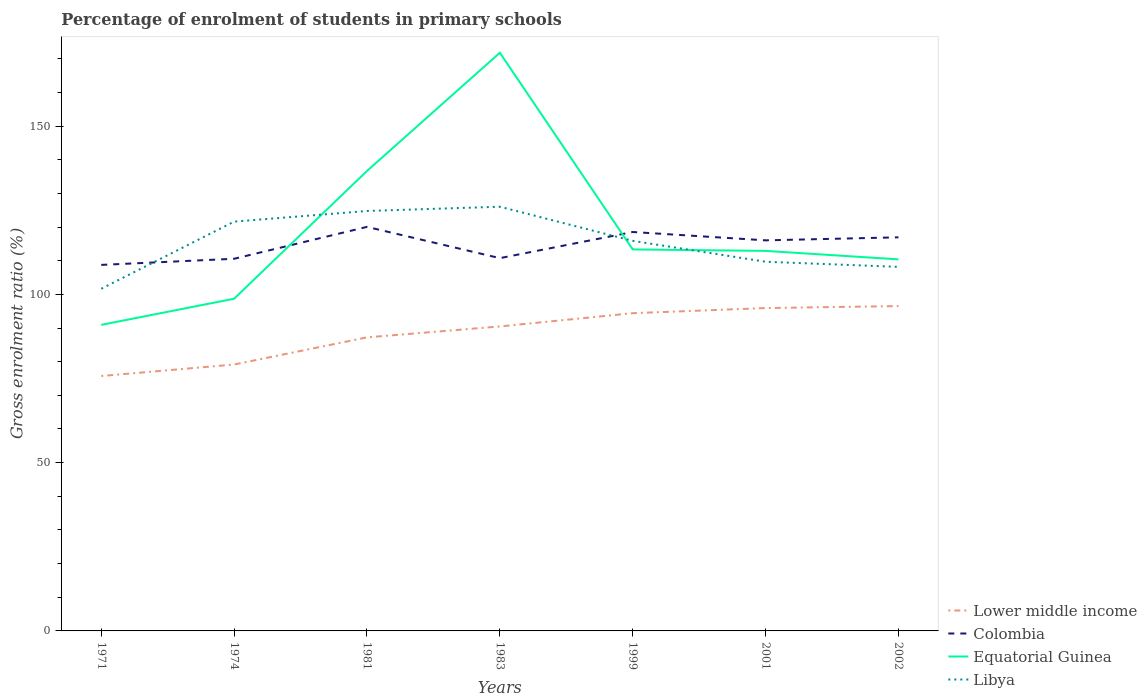How many different coloured lines are there?
Make the answer very short. 4. Is the number of lines equal to the number of legend labels?
Offer a very short reply. Yes. Across all years, what is the maximum percentage of students enrolled in primary schools in Colombia?
Offer a very short reply. 108.75. In which year was the percentage of students enrolled in primary schools in Equatorial Guinea maximum?
Ensure brevity in your answer.  1971. What is the total percentage of students enrolled in primary schools in Equatorial Guinea in the graph?
Ensure brevity in your answer.  -73.08. What is the difference between the highest and the second highest percentage of students enrolled in primary schools in Colombia?
Provide a succinct answer. 11.29. Is the percentage of students enrolled in primary schools in Libya strictly greater than the percentage of students enrolled in primary schools in Lower middle income over the years?
Make the answer very short. No. How many lines are there?
Offer a terse response. 4. What is the difference between two consecutive major ticks on the Y-axis?
Provide a short and direct response. 50. Are the values on the major ticks of Y-axis written in scientific E-notation?
Make the answer very short. No. How many legend labels are there?
Make the answer very short. 4. What is the title of the graph?
Your response must be concise. Percentage of enrolment of students in primary schools. Does "Belarus" appear as one of the legend labels in the graph?
Your answer should be very brief. No. What is the label or title of the Y-axis?
Make the answer very short. Gross enrolment ratio (%). What is the Gross enrolment ratio (%) of Lower middle income in 1971?
Your answer should be compact. 75.73. What is the Gross enrolment ratio (%) in Colombia in 1971?
Provide a short and direct response. 108.75. What is the Gross enrolment ratio (%) in Equatorial Guinea in 1971?
Ensure brevity in your answer.  90.93. What is the Gross enrolment ratio (%) of Libya in 1971?
Your answer should be compact. 101.67. What is the Gross enrolment ratio (%) of Lower middle income in 1974?
Keep it short and to the point. 79.15. What is the Gross enrolment ratio (%) of Colombia in 1974?
Provide a succinct answer. 110.57. What is the Gross enrolment ratio (%) of Equatorial Guinea in 1974?
Offer a terse response. 98.7. What is the Gross enrolment ratio (%) in Libya in 1974?
Ensure brevity in your answer.  121.61. What is the Gross enrolment ratio (%) in Lower middle income in 1981?
Offer a very short reply. 87.22. What is the Gross enrolment ratio (%) in Colombia in 1981?
Offer a terse response. 120.04. What is the Gross enrolment ratio (%) of Equatorial Guinea in 1981?
Provide a succinct answer. 136.66. What is the Gross enrolment ratio (%) of Libya in 1981?
Your answer should be very brief. 124.77. What is the Gross enrolment ratio (%) of Lower middle income in 1983?
Ensure brevity in your answer.  90.46. What is the Gross enrolment ratio (%) of Colombia in 1983?
Offer a very short reply. 110.76. What is the Gross enrolment ratio (%) of Equatorial Guinea in 1983?
Provide a short and direct response. 171.78. What is the Gross enrolment ratio (%) of Libya in 1983?
Make the answer very short. 126.03. What is the Gross enrolment ratio (%) in Lower middle income in 1999?
Offer a terse response. 94.4. What is the Gross enrolment ratio (%) of Colombia in 1999?
Your response must be concise. 118.52. What is the Gross enrolment ratio (%) of Equatorial Guinea in 1999?
Your response must be concise. 113.34. What is the Gross enrolment ratio (%) of Libya in 1999?
Give a very brief answer. 115.89. What is the Gross enrolment ratio (%) of Lower middle income in 2001?
Make the answer very short. 95.93. What is the Gross enrolment ratio (%) of Colombia in 2001?
Provide a succinct answer. 116.04. What is the Gross enrolment ratio (%) in Equatorial Guinea in 2001?
Offer a terse response. 112.91. What is the Gross enrolment ratio (%) in Libya in 2001?
Make the answer very short. 109.68. What is the Gross enrolment ratio (%) in Lower middle income in 2002?
Your answer should be very brief. 96.52. What is the Gross enrolment ratio (%) of Colombia in 2002?
Offer a terse response. 116.94. What is the Gross enrolment ratio (%) of Equatorial Guinea in 2002?
Make the answer very short. 110.39. What is the Gross enrolment ratio (%) of Libya in 2002?
Ensure brevity in your answer.  108.17. Across all years, what is the maximum Gross enrolment ratio (%) of Lower middle income?
Give a very brief answer. 96.52. Across all years, what is the maximum Gross enrolment ratio (%) in Colombia?
Your response must be concise. 120.04. Across all years, what is the maximum Gross enrolment ratio (%) in Equatorial Guinea?
Your answer should be very brief. 171.78. Across all years, what is the maximum Gross enrolment ratio (%) in Libya?
Your answer should be compact. 126.03. Across all years, what is the minimum Gross enrolment ratio (%) in Lower middle income?
Provide a succinct answer. 75.73. Across all years, what is the minimum Gross enrolment ratio (%) of Colombia?
Make the answer very short. 108.75. Across all years, what is the minimum Gross enrolment ratio (%) of Equatorial Guinea?
Your answer should be compact. 90.93. Across all years, what is the minimum Gross enrolment ratio (%) of Libya?
Keep it short and to the point. 101.67. What is the total Gross enrolment ratio (%) in Lower middle income in the graph?
Offer a terse response. 619.41. What is the total Gross enrolment ratio (%) of Colombia in the graph?
Provide a succinct answer. 801.63. What is the total Gross enrolment ratio (%) in Equatorial Guinea in the graph?
Offer a very short reply. 834.72. What is the total Gross enrolment ratio (%) of Libya in the graph?
Ensure brevity in your answer.  807.82. What is the difference between the Gross enrolment ratio (%) in Lower middle income in 1971 and that in 1974?
Offer a terse response. -3.42. What is the difference between the Gross enrolment ratio (%) of Colombia in 1971 and that in 1974?
Your answer should be compact. -1.82. What is the difference between the Gross enrolment ratio (%) in Equatorial Guinea in 1971 and that in 1974?
Offer a terse response. -7.77. What is the difference between the Gross enrolment ratio (%) of Libya in 1971 and that in 1974?
Your answer should be very brief. -19.94. What is the difference between the Gross enrolment ratio (%) of Lower middle income in 1971 and that in 1981?
Provide a short and direct response. -11.48. What is the difference between the Gross enrolment ratio (%) of Colombia in 1971 and that in 1981?
Provide a succinct answer. -11.29. What is the difference between the Gross enrolment ratio (%) of Equatorial Guinea in 1971 and that in 1981?
Provide a short and direct response. -45.73. What is the difference between the Gross enrolment ratio (%) in Libya in 1971 and that in 1981?
Provide a short and direct response. -23.11. What is the difference between the Gross enrolment ratio (%) of Lower middle income in 1971 and that in 1983?
Give a very brief answer. -14.73. What is the difference between the Gross enrolment ratio (%) in Colombia in 1971 and that in 1983?
Ensure brevity in your answer.  -2.01. What is the difference between the Gross enrolment ratio (%) in Equatorial Guinea in 1971 and that in 1983?
Make the answer very short. -80.85. What is the difference between the Gross enrolment ratio (%) of Libya in 1971 and that in 1983?
Ensure brevity in your answer.  -24.37. What is the difference between the Gross enrolment ratio (%) in Lower middle income in 1971 and that in 1999?
Your response must be concise. -18.67. What is the difference between the Gross enrolment ratio (%) of Colombia in 1971 and that in 1999?
Give a very brief answer. -9.77. What is the difference between the Gross enrolment ratio (%) of Equatorial Guinea in 1971 and that in 1999?
Keep it short and to the point. -22.41. What is the difference between the Gross enrolment ratio (%) of Libya in 1971 and that in 1999?
Give a very brief answer. -14.22. What is the difference between the Gross enrolment ratio (%) of Lower middle income in 1971 and that in 2001?
Your answer should be compact. -20.19. What is the difference between the Gross enrolment ratio (%) in Colombia in 1971 and that in 2001?
Your answer should be compact. -7.29. What is the difference between the Gross enrolment ratio (%) of Equatorial Guinea in 1971 and that in 2001?
Your response must be concise. -21.97. What is the difference between the Gross enrolment ratio (%) of Libya in 1971 and that in 2001?
Offer a very short reply. -8.02. What is the difference between the Gross enrolment ratio (%) of Lower middle income in 1971 and that in 2002?
Your answer should be very brief. -20.78. What is the difference between the Gross enrolment ratio (%) of Colombia in 1971 and that in 2002?
Keep it short and to the point. -8.19. What is the difference between the Gross enrolment ratio (%) in Equatorial Guinea in 1971 and that in 2002?
Offer a very short reply. -19.46. What is the difference between the Gross enrolment ratio (%) in Libya in 1971 and that in 2002?
Keep it short and to the point. -6.5. What is the difference between the Gross enrolment ratio (%) of Lower middle income in 1974 and that in 1981?
Provide a short and direct response. -8.06. What is the difference between the Gross enrolment ratio (%) of Colombia in 1974 and that in 1981?
Your answer should be compact. -9.47. What is the difference between the Gross enrolment ratio (%) of Equatorial Guinea in 1974 and that in 1981?
Give a very brief answer. -37.96. What is the difference between the Gross enrolment ratio (%) of Libya in 1974 and that in 1981?
Your response must be concise. -3.16. What is the difference between the Gross enrolment ratio (%) of Lower middle income in 1974 and that in 1983?
Your response must be concise. -11.31. What is the difference between the Gross enrolment ratio (%) in Colombia in 1974 and that in 1983?
Your response must be concise. -0.19. What is the difference between the Gross enrolment ratio (%) of Equatorial Guinea in 1974 and that in 1983?
Provide a succinct answer. -73.08. What is the difference between the Gross enrolment ratio (%) in Libya in 1974 and that in 1983?
Your answer should be compact. -4.43. What is the difference between the Gross enrolment ratio (%) in Lower middle income in 1974 and that in 1999?
Ensure brevity in your answer.  -15.25. What is the difference between the Gross enrolment ratio (%) in Colombia in 1974 and that in 1999?
Your answer should be very brief. -7.95. What is the difference between the Gross enrolment ratio (%) of Equatorial Guinea in 1974 and that in 1999?
Your response must be concise. -14.64. What is the difference between the Gross enrolment ratio (%) in Libya in 1974 and that in 1999?
Your response must be concise. 5.72. What is the difference between the Gross enrolment ratio (%) of Lower middle income in 1974 and that in 2001?
Ensure brevity in your answer.  -16.77. What is the difference between the Gross enrolment ratio (%) in Colombia in 1974 and that in 2001?
Make the answer very short. -5.47. What is the difference between the Gross enrolment ratio (%) of Equatorial Guinea in 1974 and that in 2001?
Keep it short and to the point. -14.21. What is the difference between the Gross enrolment ratio (%) of Libya in 1974 and that in 2001?
Offer a terse response. 11.92. What is the difference between the Gross enrolment ratio (%) in Lower middle income in 1974 and that in 2002?
Your answer should be compact. -17.37. What is the difference between the Gross enrolment ratio (%) in Colombia in 1974 and that in 2002?
Offer a terse response. -6.37. What is the difference between the Gross enrolment ratio (%) of Equatorial Guinea in 1974 and that in 2002?
Ensure brevity in your answer.  -11.69. What is the difference between the Gross enrolment ratio (%) of Libya in 1974 and that in 2002?
Give a very brief answer. 13.44. What is the difference between the Gross enrolment ratio (%) of Lower middle income in 1981 and that in 1983?
Keep it short and to the point. -3.25. What is the difference between the Gross enrolment ratio (%) in Colombia in 1981 and that in 1983?
Keep it short and to the point. 9.28. What is the difference between the Gross enrolment ratio (%) in Equatorial Guinea in 1981 and that in 1983?
Make the answer very short. -35.12. What is the difference between the Gross enrolment ratio (%) in Libya in 1981 and that in 1983?
Your answer should be very brief. -1.26. What is the difference between the Gross enrolment ratio (%) in Lower middle income in 1981 and that in 1999?
Give a very brief answer. -7.18. What is the difference between the Gross enrolment ratio (%) of Colombia in 1981 and that in 1999?
Make the answer very short. 1.52. What is the difference between the Gross enrolment ratio (%) in Equatorial Guinea in 1981 and that in 1999?
Your answer should be very brief. 23.31. What is the difference between the Gross enrolment ratio (%) in Libya in 1981 and that in 1999?
Your answer should be compact. 8.88. What is the difference between the Gross enrolment ratio (%) in Lower middle income in 1981 and that in 2001?
Provide a short and direct response. -8.71. What is the difference between the Gross enrolment ratio (%) in Colombia in 1981 and that in 2001?
Your answer should be compact. 4. What is the difference between the Gross enrolment ratio (%) of Equatorial Guinea in 1981 and that in 2001?
Make the answer very short. 23.75. What is the difference between the Gross enrolment ratio (%) of Libya in 1981 and that in 2001?
Offer a terse response. 15.09. What is the difference between the Gross enrolment ratio (%) of Lower middle income in 1981 and that in 2002?
Your answer should be very brief. -9.3. What is the difference between the Gross enrolment ratio (%) of Colombia in 1981 and that in 2002?
Your answer should be compact. 3.1. What is the difference between the Gross enrolment ratio (%) in Equatorial Guinea in 1981 and that in 2002?
Offer a very short reply. 26.27. What is the difference between the Gross enrolment ratio (%) of Libya in 1981 and that in 2002?
Provide a succinct answer. 16.6. What is the difference between the Gross enrolment ratio (%) in Lower middle income in 1983 and that in 1999?
Offer a very short reply. -3.94. What is the difference between the Gross enrolment ratio (%) in Colombia in 1983 and that in 1999?
Your answer should be compact. -7.76. What is the difference between the Gross enrolment ratio (%) in Equatorial Guinea in 1983 and that in 1999?
Give a very brief answer. 58.44. What is the difference between the Gross enrolment ratio (%) in Libya in 1983 and that in 1999?
Your response must be concise. 10.14. What is the difference between the Gross enrolment ratio (%) of Lower middle income in 1983 and that in 2001?
Make the answer very short. -5.46. What is the difference between the Gross enrolment ratio (%) in Colombia in 1983 and that in 2001?
Ensure brevity in your answer.  -5.29. What is the difference between the Gross enrolment ratio (%) of Equatorial Guinea in 1983 and that in 2001?
Ensure brevity in your answer.  58.88. What is the difference between the Gross enrolment ratio (%) in Libya in 1983 and that in 2001?
Provide a succinct answer. 16.35. What is the difference between the Gross enrolment ratio (%) in Lower middle income in 1983 and that in 2002?
Offer a terse response. -6.05. What is the difference between the Gross enrolment ratio (%) of Colombia in 1983 and that in 2002?
Provide a succinct answer. -6.18. What is the difference between the Gross enrolment ratio (%) in Equatorial Guinea in 1983 and that in 2002?
Provide a succinct answer. 61.39. What is the difference between the Gross enrolment ratio (%) of Libya in 1983 and that in 2002?
Your answer should be compact. 17.87. What is the difference between the Gross enrolment ratio (%) in Lower middle income in 1999 and that in 2001?
Offer a terse response. -1.53. What is the difference between the Gross enrolment ratio (%) of Colombia in 1999 and that in 2001?
Give a very brief answer. 2.48. What is the difference between the Gross enrolment ratio (%) of Equatorial Guinea in 1999 and that in 2001?
Offer a very short reply. 0.44. What is the difference between the Gross enrolment ratio (%) in Libya in 1999 and that in 2001?
Provide a succinct answer. 6.21. What is the difference between the Gross enrolment ratio (%) of Lower middle income in 1999 and that in 2002?
Give a very brief answer. -2.12. What is the difference between the Gross enrolment ratio (%) in Colombia in 1999 and that in 2002?
Offer a very short reply. 1.58. What is the difference between the Gross enrolment ratio (%) of Equatorial Guinea in 1999 and that in 2002?
Your answer should be very brief. 2.95. What is the difference between the Gross enrolment ratio (%) in Libya in 1999 and that in 2002?
Your answer should be very brief. 7.72. What is the difference between the Gross enrolment ratio (%) in Lower middle income in 2001 and that in 2002?
Make the answer very short. -0.59. What is the difference between the Gross enrolment ratio (%) of Colombia in 2001 and that in 2002?
Give a very brief answer. -0.9. What is the difference between the Gross enrolment ratio (%) of Equatorial Guinea in 2001 and that in 2002?
Keep it short and to the point. 2.51. What is the difference between the Gross enrolment ratio (%) in Libya in 2001 and that in 2002?
Make the answer very short. 1.52. What is the difference between the Gross enrolment ratio (%) of Lower middle income in 1971 and the Gross enrolment ratio (%) of Colombia in 1974?
Your answer should be very brief. -34.84. What is the difference between the Gross enrolment ratio (%) of Lower middle income in 1971 and the Gross enrolment ratio (%) of Equatorial Guinea in 1974?
Provide a succinct answer. -22.97. What is the difference between the Gross enrolment ratio (%) in Lower middle income in 1971 and the Gross enrolment ratio (%) in Libya in 1974?
Ensure brevity in your answer.  -45.87. What is the difference between the Gross enrolment ratio (%) in Colombia in 1971 and the Gross enrolment ratio (%) in Equatorial Guinea in 1974?
Your answer should be compact. 10.05. What is the difference between the Gross enrolment ratio (%) of Colombia in 1971 and the Gross enrolment ratio (%) of Libya in 1974?
Ensure brevity in your answer.  -12.86. What is the difference between the Gross enrolment ratio (%) of Equatorial Guinea in 1971 and the Gross enrolment ratio (%) of Libya in 1974?
Ensure brevity in your answer.  -30.67. What is the difference between the Gross enrolment ratio (%) of Lower middle income in 1971 and the Gross enrolment ratio (%) of Colombia in 1981?
Provide a succinct answer. -44.31. What is the difference between the Gross enrolment ratio (%) in Lower middle income in 1971 and the Gross enrolment ratio (%) in Equatorial Guinea in 1981?
Offer a very short reply. -60.92. What is the difference between the Gross enrolment ratio (%) of Lower middle income in 1971 and the Gross enrolment ratio (%) of Libya in 1981?
Ensure brevity in your answer.  -49.04. What is the difference between the Gross enrolment ratio (%) of Colombia in 1971 and the Gross enrolment ratio (%) of Equatorial Guinea in 1981?
Ensure brevity in your answer.  -27.91. What is the difference between the Gross enrolment ratio (%) of Colombia in 1971 and the Gross enrolment ratio (%) of Libya in 1981?
Keep it short and to the point. -16.02. What is the difference between the Gross enrolment ratio (%) in Equatorial Guinea in 1971 and the Gross enrolment ratio (%) in Libya in 1981?
Your answer should be compact. -33.84. What is the difference between the Gross enrolment ratio (%) in Lower middle income in 1971 and the Gross enrolment ratio (%) in Colombia in 1983?
Ensure brevity in your answer.  -35.02. What is the difference between the Gross enrolment ratio (%) in Lower middle income in 1971 and the Gross enrolment ratio (%) in Equatorial Guinea in 1983?
Provide a short and direct response. -96.05. What is the difference between the Gross enrolment ratio (%) of Lower middle income in 1971 and the Gross enrolment ratio (%) of Libya in 1983?
Ensure brevity in your answer.  -50.3. What is the difference between the Gross enrolment ratio (%) of Colombia in 1971 and the Gross enrolment ratio (%) of Equatorial Guinea in 1983?
Your answer should be compact. -63.03. What is the difference between the Gross enrolment ratio (%) of Colombia in 1971 and the Gross enrolment ratio (%) of Libya in 1983?
Offer a very short reply. -17.28. What is the difference between the Gross enrolment ratio (%) of Equatorial Guinea in 1971 and the Gross enrolment ratio (%) of Libya in 1983?
Offer a terse response. -35.1. What is the difference between the Gross enrolment ratio (%) in Lower middle income in 1971 and the Gross enrolment ratio (%) in Colombia in 1999?
Your response must be concise. -42.79. What is the difference between the Gross enrolment ratio (%) in Lower middle income in 1971 and the Gross enrolment ratio (%) in Equatorial Guinea in 1999?
Offer a terse response. -37.61. What is the difference between the Gross enrolment ratio (%) of Lower middle income in 1971 and the Gross enrolment ratio (%) of Libya in 1999?
Your answer should be compact. -40.16. What is the difference between the Gross enrolment ratio (%) of Colombia in 1971 and the Gross enrolment ratio (%) of Equatorial Guinea in 1999?
Your answer should be compact. -4.59. What is the difference between the Gross enrolment ratio (%) of Colombia in 1971 and the Gross enrolment ratio (%) of Libya in 1999?
Your answer should be very brief. -7.14. What is the difference between the Gross enrolment ratio (%) in Equatorial Guinea in 1971 and the Gross enrolment ratio (%) in Libya in 1999?
Make the answer very short. -24.96. What is the difference between the Gross enrolment ratio (%) in Lower middle income in 1971 and the Gross enrolment ratio (%) in Colombia in 2001?
Make the answer very short. -40.31. What is the difference between the Gross enrolment ratio (%) of Lower middle income in 1971 and the Gross enrolment ratio (%) of Equatorial Guinea in 2001?
Ensure brevity in your answer.  -37.17. What is the difference between the Gross enrolment ratio (%) in Lower middle income in 1971 and the Gross enrolment ratio (%) in Libya in 2001?
Give a very brief answer. -33.95. What is the difference between the Gross enrolment ratio (%) of Colombia in 1971 and the Gross enrolment ratio (%) of Equatorial Guinea in 2001?
Offer a terse response. -4.15. What is the difference between the Gross enrolment ratio (%) of Colombia in 1971 and the Gross enrolment ratio (%) of Libya in 2001?
Give a very brief answer. -0.93. What is the difference between the Gross enrolment ratio (%) in Equatorial Guinea in 1971 and the Gross enrolment ratio (%) in Libya in 2001?
Your response must be concise. -18.75. What is the difference between the Gross enrolment ratio (%) of Lower middle income in 1971 and the Gross enrolment ratio (%) of Colombia in 2002?
Ensure brevity in your answer.  -41.21. What is the difference between the Gross enrolment ratio (%) of Lower middle income in 1971 and the Gross enrolment ratio (%) of Equatorial Guinea in 2002?
Keep it short and to the point. -34.66. What is the difference between the Gross enrolment ratio (%) in Lower middle income in 1971 and the Gross enrolment ratio (%) in Libya in 2002?
Your response must be concise. -32.43. What is the difference between the Gross enrolment ratio (%) of Colombia in 1971 and the Gross enrolment ratio (%) of Equatorial Guinea in 2002?
Offer a terse response. -1.64. What is the difference between the Gross enrolment ratio (%) in Colombia in 1971 and the Gross enrolment ratio (%) in Libya in 2002?
Offer a terse response. 0.58. What is the difference between the Gross enrolment ratio (%) of Equatorial Guinea in 1971 and the Gross enrolment ratio (%) of Libya in 2002?
Provide a succinct answer. -17.23. What is the difference between the Gross enrolment ratio (%) in Lower middle income in 1974 and the Gross enrolment ratio (%) in Colombia in 1981?
Keep it short and to the point. -40.89. What is the difference between the Gross enrolment ratio (%) in Lower middle income in 1974 and the Gross enrolment ratio (%) in Equatorial Guinea in 1981?
Provide a succinct answer. -57.51. What is the difference between the Gross enrolment ratio (%) of Lower middle income in 1974 and the Gross enrolment ratio (%) of Libya in 1981?
Offer a terse response. -45.62. What is the difference between the Gross enrolment ratio (%) of Colombia in 1974 and the Gross enrolment ratio (%) of Equatorial Guinea in 1981?
Your answer should be compact. -26.09. What is the difference between the Gross enrolment ratio (%) in Colombia in 1974 and the Gross enrolment ratio (%) in Libya in 1981?
Give a very brief answer. -14.2. What is the difference between the Gross enrolment ratio (%) in Equatorial Guinea in 1974 and the Gross enrolment ratio (%) in Libya in 1981?
Offer a terse response. -26.07. What is the difference between the Gross enrolment ratio (%) in Lower middle income in 1974 and the Gross enrolment ratio (%) in Colombia in 1983?
Ensure brevity in your answer.  -31.61. What is the difference between the Gross enrolment ratio (%) in Lower middle income in 1974 and the Gross enrolment ratio (%) in Equatorial Guinea in 1983?
Give a very brief answer. -92.63. What is the difference between the Gross enrolment ratio (%) in Lower middle income in 1974 and the Gross enrolment ratio (%) in Libya in 1983?
Provide a short and direct response. -46.88. What is the difference between the Gross enrolment ratio (%) of Colombia in 1974 and the Gross enrolment ratio (%) of Equatorial Guinea in 1983?
Provide a short and direct response. -61.21. What is the difference between the Gross enrolment ratio (%) of Colombia in 1974 and the Gross enrolment ratio (%) of Libya in 1983?
Keep it short and to the point. -15.46. What is the difference between the Gross enrolment ratio (%) in Equatorial Guinea in 1974 and the Gross enrolment ratio (%) in Libya in 1983?
Ensure brevity in your answer.  -27.33. What is the difference between the Gross enrolment ratio (%) in Lower middle income in 1974 and the Gross enrolment ratio (%) in Colombia in 1999?
Offer a very short reply. -39.37. What is the difference between the Gross enrolment ratio (%) in Lower middle income in 1974 and the Gross enrolment ratio (%) in Equatorial Guinea in 1999?
Ensure brevity in your answer.  -34.19. What is the difference between the Gross enrolment ratio (%) in Lower middle income in 1974 and the Gross enrolment ratio (%) in Libya in 1999?
Keep it short and to the point. -36.74. What is the difference between the Gross enrolment ratio (%) in Colombia in 1974 and the Gross enrolment ratio (%) in Equatorial Guinea in 1999?
Give a very brief answer. -2.77. What is the difference between the Gross enrolment ratio (%) of Colombia in 1974 and the Gross enrolment ratio (%) of Libya in 1999?
Offer a very short reply. -5.32. What is the difference between the Gross enrolment ratio (%) in Equatorial Guinea in 1974 and the Gross enrolment ratio (%) in Libya in 1999?
Provide a short and direct response. -17.19. What is the difference between the Gross enrolment ratio (%) in Lower middle income in 1974 and the Gross enrolment ratio (%) in Colombia in 2001?
Your answer should be compact. -36.89. What is the difference between the Gross enrolment ratio (%) in Lower middle income in 1974 and the Gross enrolment ratio (%) in Equatorial Guinea in 2001?
Make the answer very short. -33.75. What is the difference between the Gross enrolment ratio (%) in Lower middle income in 1974 and the Gross enrolment ratio (%) in Libya in 2001?
Provide a succinct answer. -30.53. What is the difference between the Gross enrolment ratio (%) in Colombia in 1974 and the Gross enrolment ratio (%) in Equatorial Guinea in 2001?
Keep it short and to the point. -2.33. What is the difference between the Gross enrolment ratio (%) in Colombia in 1974 and the Gross enrolment ratio (%) in Libya in 2001?
Provide a short and direct response. 0.89. What is the difference between the Gross enrolment ratio (%) in Equatorial Guinea in 1974 and the Gross enrolment ratio (%) in Libya in 2001?
Your response must be concise. -10.98. What is the difference between the Gross enrolment ratio (%) in Lower middle income in 1974 and the Gross enrolment ratio (%) in Colombia in 2002?
Your answer should be compact. -37.79. What is the difference between the Gross enrolment ratio (%) in Lower middle income in 1974 and the Gross enrolment ratio (%) in Equatorial Guinea in 2002?
Make the answer very short. -31.24. What is the difference between the Gross enrolment ratio (%) of Lower middle income in 1974 and the Gross enrolment ratio (%) of Libya in 2002?
Give a very brief answer. -29.01. What is the difference between the Gross enrolment ratio (%) of Colombia in 1974 and the Gross enrolment ratio (%) of Equatorial Guinea in 2002?
Your answer should be compact. 0.18. What is the difference between the Gross enrolment ratio (%) in Colombia in 1974 and the Gross enrolment ratio (%) in Libya in 2002?
Your answer should be compact. 2.4. What is the difference between the Gross enrolment ratio (%) in Equatorial Guinea in 1974 and the Gross enrolment ratio (%) in Libya in 2002?
Give a very brief answer. -9.47. What is the difference between the Gross enrolment ratio (%) of Lower middle income in 1981 and the Gross enrolment ratio (%) of Colombia in 1983?
Keep it short and to the point. -23.54. What is the difference between the Gross enrolment ratio (%) in Lower middle income in 1981 and the Gross enrolment ratio (%) in Equatorial Guinea in 1983?
Provide a short and direct response. -84.57. What is the difference between the Gross enrolment ratio (%) in Lower middle income in 1981 and the Gross enrolment ratio (%) in Libya in 1983?
Your answer should be very brief. -38.82. What is the difference between the Gross enrolment ratio (%) in Colombia in 1981 and the Gross enrolment ratio (%) in Equatorial Guinea in 1983?
Your answer should be very brief. -51.74. What is the difference between the Gross enrolment ratio (%) in Colombia in 1981 and the Gross enrolment ratio (%) in Libya in 1983?
Offer a very short reply. -5.99. What is the difference between the Gross enrolment ratio (%) in Equatorial Guinea in 1981 and the Gross enrolment ratio (%) in Libya in 1983?
Ensure brevity in your answer.  10.63. What is the difference between the Gross enrolment ratio (%) in Lower middle income in 1981 and the Gross enrolment ratio (%) in Colombia in 1999?
Your response must be concise. -31.31. What is the difference between the Gross enrolment ratio (%) of Lower middle income in 1981 and the Gross enrolment ratio (%) of Equatorial Guinea in 1999?
Your response must be concise. -26.13. What is the difference between the Gross enrolment ratio (%) of Lower middle income in 1981 and the Gross enrolment ratio (%) of Libya in 1999?
Provide a succinct answer. -28.67. What is the difference between the Gross enrolment ratio (%) in Colombia in 1981 and the Gross enrolment ratio (%) in Equatorial Guinea in 1999?
Offer a very short reply. 6.7. What is the difference between the Gross enrolment ratio (%) in Colombia in 1981 and the Gross enrolment ratio (%) in Libya in 1999?
Your answer should be very brief. 4.15. What is the difference between the Gross enrolment ratio (%) in Equatorial Guinea in 1981 and the Gross enrolment ratio (%) in Libya in 1999?
Keep it short and to the point. 20.77. What is the difference between the Gross enrolment ratio (%) in Lower middle income in 1981 and the Gross enrolment ratio (%) in Colombia in 2001?
Ensure brevity in your answer.  -28.83. What is the difference between the Gross enrolment ratio (%) in Lower middle income in 1981 and the Gross enrolment ratio (%) in Equatorial Guinea in 2001?
Keep it short and to the point. -25.69. What is the difference between the Gross enrolment ratio (%) in Lower middle income in 1981 and the Gross enrolment ratio (%) in Libya in 2001?
Offer a very short reply. -22.47. What is the difference between the Gross enrolment ratio (%) of Colombia in 1981 and the Gross enrolment ratio (%) of Equatorial Guinea in 2001?
Ensure brevity in your answer.  7.14. What is the difference between the Gross enrolment ratio (%) of Colombia in 1981 and the Gross enrolment ratio (%) of Libya in 2001?
Ensure brevity in your answer.  10.36. What is the difference between the Gross enrolment ratio (%) of Equatorial Guinea in 1981 and the Gross enrolment ratio (%) of Libya in 2001?
Your answer should be compact. 26.98. What is the difference between the Gross enrolment ratio (%) of Lower middle income in 1981 and the Gross enrolment ratio (%) of Colombia in 2002?
Give a very brief answer. -29.73. What is the difference between the Gross enrolment ratio (%) in Lower middle income in 1981 and the Gross enrolment ratio (%) in Equatorial Guinea in 2002?
Ensure brevity in your answer.  -23.18. What is the difference between the Gross enrolment ratio (%) of Lower middle income in 1981 and the Gross enrolment ratio (%) of Libya in 2002?
Offer a very short reply. -20.95. What is the difference between the Gross enrolment ratio (%) of Colombia in 1981 and the Gross enrolment ratio (%) of Equatorial Guinea in 2002?
Provide a short and direct response. 9.65. What is the difference between the Gross enrolment ratio (%) of Colombia in 1981 and the Gross enrolment ratio (%) of Libya in 2002?
Your answer should be very brief. 11.87. What is the difference between the Gross enrolment ratio (%) in Equatorial Guinea in 1981 and the Gross enrolment ratio (%) in Libya in 2002?
Your answer should be compact. 28.49. What is the difference between the Gross enrolment ratio (%) in Lower middle income in 1983 and the Gross enrolment ratio (%) in Colombia in 1999?
Offer a very short reply. -28.06. What is the difference between the Gross enrolment ratio (%) in Lower middle income in 1983 and the Gross enrolment ratio (%) in Equatorial Guinea in 1999?
Your response must be concise. -22.88. What is the difference between the Gross enrolment ratio (%) of Lower middle income in 1983 and the Gross enrolment ratio (%) of Libya in 1999?
Provide a short and direct response. -25.43. What is the difference between the Gross enrolment ratio (%) of Colombia in 1983 and the Gross enrolment ratio (%) of Equatorial Guinea in 1999?
Your answer should be very brief. -2.59. What is the difference between the Gross enrolment ratio (%) of Colombia in 1983 and the Gross enrolment ratio (%) of Libya in 1999?
Offer a very short reply. -5.13. What is the difference between the Gross enrolment ratio (%) of Equatorial Guinea in 1983 and the Gross enrolment ratio (%) of Libya in 1999?
Provide a short and direct response. 55.89. What is the difference between the Gross enrolment ratio (%) in Lower middle income in 1983 and the Gross enrolment ratio (%) in Colombia in 2001?
Your answer should be very brief. -25.58. What is the difference between the Gross enrolment ratio (%) in Lower middle income in 1983 and the Gross enrolment ratio (%) in Equatorial Guinea in 2001?
Your answer should be compact. -22.44. What is the difference between the Gross enrolment ratio (%) of Lower middle income in 1983 and the Gross enrolment ratio (%) of Libya in 2001?
Your response must be concise. -19.22. What is the difference between the Gross enrolment ratio (%) of Colombia in 1983 and the Gross enrolment ratio (%) of Equatorial Guinea in 2001?
Provide a short and direct response. -2.15. What is the difference between the Gross enrolment ratio (%) of Colombia in 1983 and the Gross enrolment ratio (%) of Libya in 2001?
Offer a very short reply. 1.07. What is the difference between the Gross enrolment ratio (%) in Equatorial Guinea in 1983 and the Gross enrolment ratio (%) in Libya in 2001?
Offer a very short reply. 62.1. What is the difference between the Gross enrolment ratio (%) in Lower middle income in 1983 and the Gross enrolment ratio (%) in Colombia in 2002?
Offer a very short reply. -26.48. What is the difference between the Gross enrolment ratio (%) of Lower middle income in 1983 and the Gross enrolment ratio (%) of Equatorial Guinea in 2002?
Provide a succinct answer. -19.93. What is the difference between the Gross enrolment ratio (%) in Lower middle income in 1983 and the Gross enrolment ratio (%) in Libya in 2002?
Your response must be concise. -17.7. What is the difference between the Gross enrolment ratio (%) of Colombia in 1983 and the Gross enrolment ratio (%) of Equatorial Guinea in 2002?
Your answer should be very brief. 0.36. What is the difference between the Gross enrolment ratio (%) in Colombia in 1983 and the Gross enrolment ratio (%) in Libya in 2002?
Make the answer very short. 2.59. What is the difference between the Gross enrolment ratio (%) of Equatorial Guinea in 1983 and the Gross enrolment ratio (%) of Libya in 2002?
Offer a terse response. 63.62. What is the difference between the Gross enrolment ratio (%) in Lower middle income in 1999 and the Gross enrolment ratio (%) in Colombia in 2001?
Offer a terse response. -21.64. What is the difference between the Gross enrolment ratio (%) in Lower middle income in 1999 and the Gross enrolment ratio (%) in Equatorial Guinea in 2001?
Keep it short and to the point. -18.5. What is the difference between the Gross enrolment ratio (%) in Lower middle income in 1999 and the Gross enrolment ratio (%) in Libya in 2001?
Your response must be concise. -15.28. What is the difference between the Gross enrolment ratio (%) in Colombia in 1999 and the Gross enrolment ratio (%) in Equatorial Guinea in 2001?
Offer a terse response. 5.62. What is the difference between the Gross enrolment ratio (%) in Colombia in 1999 and the Gross enrolment ratio (%) in Libya in 2001?
Give a very brief answer. 8.84. What is the difference between the Gross enrolment ratio (%) in Equatorial Guinea in 1999 and the Gross enrolment ratio (%) in Libya in 2001?
Provide a succinct answer. 3.66. What is the difference between the Gross enrolment ratio (%) of Lower middle income in 1999 and the Gross enrolment ratio (%) of Colombia in 2002?
Offer a very short reply. -22.54. What is the difference between the Gross enrolment ratio (%) in Lower middle income in 1999 and the Gross enrolment ratio (%) in Equatorial Guinea in 2002?
Provide a short and direct response. -15.99. What is the difference between the Gross enrolment ratio (%) of Lower middle income in 1999 and the Gross enrolment ratio (%) of Libya in 2002?
Ensure brevity in your answer.  -13.77. What is the difference between the Gross enrolment ratio (%) in Colombia in 1999 and the Gross enrolment ratio (%) in Equatorial Guinea in 2002?
Offer a very short reply. 8.13. What is the difference between the Gross enrolment ratio (%) of Colombia in 1999 and the Gross enrolment ratio (%) of Libya in 2002?
Your response must be concise. 10.36. What is the difference between the Gross enrolment ratio (%) of Equatorial Guinea in 1999 and the Gross enrolment ratio (%) of Libya in 2002?
Offer a very short reply. 5.18. What is the difference between the Gross enrolment ratio (%) in Lower middle income in 2001 and the Gross enrolment ratio (%) in Colombia in 2002?
Ensure brevity in your answer.  -21.01. What is the difference between the Gross enrolment ratio (%) in Lower middle income in 2001 and the Gross enrolment ratio (%) in Equatorial Guinea in 2002?
Provide a succinct answer. -14.47. What is the difference between the Gross enrolment ratio (%) of Lower middle income in 2001 and the Gross enrolment ratio (%) of Libya in 2002?
Your answer should be very brief. -12.24. What is the difference between the Gross enrolment ratio (%) of Colombia in 2001 and the Gross enrolment ratio (%) of Equatorial Guinea in 2002?
Your answer should be compact. 5.65. What is the difference between the Gross enrolment ratio (%) of Colombia in 2001 and the Gross enrolment ratio (%) of Libya in 2002?
Provide a short and direct response. 7.88. What is the difference between the Gross enrolment ratio (%) of Equatorial Guinea in 2001 and the Gross enrolment ratio (%) of Libya in 2002?
Ensure brevity in your answer.  4.74. What is the average Gross enrolment ratio (%) in Lower middle income per year?
Your answer should be very brief. 88.49. What is the average Gross enrolment ratio (%) of Colombia per year?
Ensure brevity in your answer.  114.52. What is the average Gross enrolment ratio (%) in Equatorial Guinea per year?
Offer a very short reply. 119.25. What is the average Gross enrolment ratio (%) in Libya per year?
Your answer should be compact. 115.4. In the year 1971, what is the difference between the Gross enrolment ratio (%) in Lower middle income and Gross enrolment ratio (%) in Colombia?
Ensure brevity in your answer.  -33.02. In the year 1971, what is the difference between the Gross enrolment ratio (%) in Lower middle income and Gross enrolment ratio (%) in Equatorial Guinea?
Your answer should be compact. -15.2. In the year 1971, what is the difference between the Gross enrolment ratio (%) of Lower middle income and Gross enrolment ratio (%) of Libya?
Provide a short and direct response. -25.93. In the year 1971, what is the difference between the Gross enrolment ratio (%) of Colombia and Gross enrolment ratio (%) of Equatorial Guinea?
Keep it short and to the point. 17.82. In the year 1971, what is the difference between the Gross enrolment ratio (%) of Colombia and Gross enrolment ratio (%) of Libya?
Give a very brief answer. 7.08. In the year 1971, what is the difference between the Gross enrolment ratio (%) in Equatorial Guinea and Gross enrolment ratio (%) in Libya?
Provide a succinct answer. -10.73. In the year 1974, what is the difference between the Gross enrolment ratio (%) in Lower middle income and Gross enrolment ratio (%) in Colombia?
Your answer should be very brief. -31.42. In the year 1974, what is the difference between the Gross enrolment ratio (%) of Lower middle income and Gross enrolment ratio (%) of Equatorial Guinea?
Provide a short and direct response. -19.55. In the year 1974, what is the difference between the Gross enrolment ratio (%) of Lower middle income and Gross enrolment ratio (%) of Libya?
Keep it short and to the point. -42.45. In the year 1974, what is the difference between the Gross enrolment ratio (%) of Colombia and Gross enrolment ratio (%) of Equatorial Guinea?
Provide a succinct answer. 11.87. In the year 1974, what is the difference between the Gross enrolment ratio (%) in Colombia and Gross enrolment ratio (%) in Libya?
Provide a succinct answer. -11.04. In the year 1974, what is the difference between the Gross enrolment ratio (%) in Equatorial Guinea and Gross enrolment ratio (%) in Libya?
Ensure brevity in your answer.  -22.91. In the year 1981, what is the difference between the Gross enrolment ratio (%) of Lower middle income and Gross enrolment ratio (%) of Colombia?
Your response must be concise. -32.83. In the year 1981, what is the difference between the Gross enrolment ratio (%) in Lower middle income and Gross enrolment ratio (%) in Equatorial Guinea?
Keep it short and to the point. -49.44. In the year 1981, what is the difference between the Gross enrolment ratio (%) in Lower middle income and Gross enrolment ratio (%) in Libya?
Your answer should be compact. -37.55. In the year 1981, what is the difference between the Gross enrolment ratio (%) in Colombia and Gross enrolment ratio (%) in Equatorial Guinea?
Ensure brevity in your answer.  -16.62. In the year 1981, what is the difference between the Gross enrolment ratio (%) in Colombia and Gross enrolment ratio (%) in Libya?
Offer a very short reply. -4.73. In the year 1981, what is the difference between the Gross enrolment ratio (%) of Equatorial Guinea and Gross enrolment ratio (%) of Libya?
Your answer should be very brief. 11.89. In the year 1983, what is the difference between the Gross enrolment ratio (%) in Lower middle income and Gross enrolment ratio (%) in Colombia?
Ensure brevity in your answer.  -20.29. In the year 1983, what is the difference between the Gross enrolment ratio (%) in Lower middle income and Gross enrolment ratio (%) in Equatorial Guinea?
Make the answer very short. -81.32. In the year 1983, what is the difference between the Gross enrolment ratio (%) of Lower middle income and Gross enrolment ratio (%) of Libya?
Keep it short and to the point. -35.57. In the year 1983, what is the difference between the Gross enrolment ratio (%) in Colombia and Gross enrolment ratio (%) in Equatorial Guinea?
Offer a very short reply. -61.03. In the year 1983, what is the difference between the Gross enrolment ratio (%) in Colombia and Gross enrolment ratio (%) in Libya?
Ensure brevity in your answer.  -15.28. In the year 1983, what is the difference between the Gross enrolment ratio (%) in Equatorial Guinea and Gross enrolment ratio (%) in Libya?
Your response must be concise. 45.75. In the year 1999, what is the difference between the Gross enrolment ratio (%) of Lower middle income and Gross enrolment ratio (%) of Colombia?
Make the answer very short. -24.12. In the year 1999, what is the difference between the Gross enrolment ratio (%) in Lower middle income and Gross enrolment ratio (%) in Equatorial Guinea?
Your answer should be very brief. -18.94. In the year 1999, what is the difference between the Gross enrolment ratio (%) in Lower middle income and Gross enrolment ratio (%) in Libya?
Make the answer very short. -21.49. In the year 1999, what is the difference between the Gross enrolment ratio (%) in Colombia and Gross enrolment ratio (%) in Equatorial Guinea?
Give a very brief answer. 5.18. In the year 1999, what is the difference between the Gross enrolment ratio (%) of Colombia and Gross enrolment ratio (%) of Libya?
Make the answer very short. 2.63. In the year 1999, what is the difference between the Gross enrolment ratio (%) in Equatorial Guinea and Gross enrolment ratio (%) in Libya?
Provide a short and direct response. -2.55. In the year 2001, what is the difference between the Gross enrolment ratio (%) in Lower middle income and Gross enrolment ratio (%) in Colombia?
Provide a succinct answer. -20.12. In the year 2001, what is the difference between the Gross enrolment ratio (%) of Lower middle income and Gross enrolment ratio (%) of Equatorial Guinea?
Ensure brevity in your answer.  -16.98. In the year 2001, what is the difference between the Gross enrolment ratio (%) in Lower middle income and Gross enrolment ratio (%) in Libya?
Make the answer very short. -13.76. In the year 2001, what is the difference between the Gross enrolment ratio (%) of Colombia and Gross enrolment ratio (%) of Equatorial Guinea?
Make the answer very short. 3.14. In the year 2001, what is the difference between the Gross enrolment ratio (%) of Colombia and Gross enrolment ratio (%) of Libya?
Give a very brief answer. 6.36. In the year 2001, what is the difference between the Gross enrolment ratio (%) in Equatorial Guinea and Gross enrolment ratio (%) in Libya?
Ensure brevity in your answer.  3.22. In the year 2002, what is the difference between the Gross enrolment ratio (%) of Lower middle income and Gross enrolment ratio (%) of Colombia?
Ensure brevity in your answer.  -20.42. In the year 2002, what is the difference between the Gross enrolment ratio (%) in Lower middle income and Gross enrolment ratio (%) in Equatorial Guinea?
Provide a short and direct response. -13.88. In the year 2002, what is the difference between the Gross enrolment ratio (%) in Lower middle income and Gross enrolment ratio (%) in Libya?
Provide a short and direct response. -11.65. In the year 2002, what is the difference between the Gross enrolment ratio (%) of Colombia and Gross enrolment ratio (%) of Equatorial Guinea?
Give a very brief answer. 6.55. In the year 2002, what is the difference between the Gross enrolment ratio (%) of Colombia and Gross enrolment ratio (%) of Libya?
Ensure brevity in your answer.  8.77. In the year 2002, what is the difference between the Gross enrolment ratio (%) in Equatorial Guinea and Gross enrolment ratio (%) in Libya?
Provide a short and direct response. 2.23. What is the ratio of the Gross enrolment ratio (%) of Lower middle income in 1971 to that in 1974?
Ensure brevity in your answer.  0.96. What is the ratio of the Gross enrolment ratio (%) in Colombia in 1971 to that in 1974?
Keep it short and to the point. 0.98. What is the ratio of the Gross enrolment ratio (%) of Equatorial Guinea in 1971 to that in 1974?
Offer a terse response. 0.92. What is the ratio of the Gross enrolment ratio (%) in Libya in 1971 to that in 1974?
Provide a succinct answer. 0.84. What is the ratio of the Gross enrolment ratio (%) of Lower middle income in 1971 to that in 1981?
Ensure brevity in your answer.  0.87. What is the ratio of the Gross enrolment ratio (%) in Colombia in 1971 to that in 1981?
Your answer should be very brief. 0.91. What is the ratio of the Gross enrolment ratio (%) in Equatorial Guinea in 1971 to that in 1981?
Ensure brevity in your answer.  0.67. What is the ratio of the Gross enrolment ratio (%) in Libya in 1971 to that in 1981?
Provide a short and direct response. 0.81. What is the ratio of the Gross enrolment ratio (%) in Lower middle income in 1971 to that in 1983?
Your answer should be compact. 0.84. What is the ratio of the Gross enrolment ratio (%) of Colombia in 1971 to that in 1983?
Give a very brief answer. 0.98. What is the ratio of the Gross enrolment ratio (%) of Equatorial Guinea in 1971 to that in 1983?
Your answer should be compact. 0.53. What is the ratio of the Gross enrolment ratio (%) of Libya in 1971 to that in 1983?
Your answer should be very brief. 0.81. What is the ratio of the Gross enrolment ratio (%) of Lower middle income in 1971 to that in 1999?
Offer a very short reply. 0.8. What is the ratio of the Gross enrolment ratio (%) in Colombia in 1971 to that in 1999?
Provide a succinct answer. 0.92. What is the ratio of the Gross enrolment ratio (%) of Equatorial Guinea in 1971 to that in 1999?
Your answer should be compact. 0.8. What is the ratio of the Gross enrolment ratio (%) of Libya in 1971 to that in 1999?
Your answer should be very brief. 0.88. What is the ratio of the Gross enrolment ratio (%) in Lower middle income in 1971 to that in 2001?
Offer a very short reply. 0.79. What is the ratio of the Gross enrolment ratio (%) in Colombia in 1971 to that in 2001?
Make the answer very short. 0.94. What is the ratio of the Gross enrolment ratio (%) of Equatorial Guinea in 1971 to that in 2001?
Offer a terse response. 0.81. What is the ratio of the Gross enrolment ratio (%) in Libya in 1971 to that in 2001?
Offer a very short reply. 0.93. What is the ratio of the Gross enrolment ratio (%) in Lower middle income in 1971 to that in 2002?
Provide a short and direct response. 0.78. What is the ratio of the Gross enrolment ratio (%) in Colombia in 1971 to that in 2002?
Your answer should be compact. 0.93. What is the ratio of the Gross enrolment ratio (%) of Equatorial Guinea in 1971 to that in 2002?
Make the answer very short. 0.82. What is the ratio of the Gross enrolment ratio (%) in Libya in 1971 to that in 2002?
Make the answer very short. 0.94. What is the ratio of the Gross enrolment ratio (%) in Lower middle income in 1974 to that in 1981?
Make the answer very short. 0.91. What is the ratio of the Gross enrolment ratio (%) of Colombia in 1974 to that in 1981?
Your answer should be very brief. 0.92. What is the ratio of the Gross enrolment ratio (%) in Equatorial Guinea in 1974 to that in 1981?
Offer a terse response. 0.72. What is the ratio of the Gross enrolment ratio (%) in Libya in 1974 to that in 1981?
Make the answer very short. 0.97. What is the ratio of the Gross enrolment ratio (%) of Colombia in 1974 to that in 1983?
Provide a succinct answer. 1. What is the ratio of the Gross enrolment ratio (%) in Equatorial Guinea in 1974 to that in 1983?
Offer a terse response. 0.57. What is the ratio of the Gross enrolment ratio (%) in Libya in 1974 to that in 1983?
Your answer should be compact. 0.96. What is the ratio of the Gross enrolment ratio (%) of Lower middle income in 1974 to that in 1999?
Provide a succinct answer. 0.84. What is the ratio of the Gross enrolment ratio (%) in Colombia in 1974 to that in 1999?
Provide a succinct answer. 0.93. What is the ratio of the Gross enrolment ratio (%) of Equatorial Guinea in 1974 to that in 1999?
Provide a succinct answer. 0.87. What is the ratio of the Gross enrolment ratio (%) in Libya in 1974 to that in 1999?
Provide a succinct answer. 1.05. What is the ratio of the Gross enrolment ratio (%) of Lower middle income in 1974 to that in 2001?
Make the answer very short. 0.83. What is the ratio of the Gross enrolment ratio (%) of Colombia in 1974 to that in 2001?
Your response must be concise. 0.95. What is the ratio of the Gross enrolment ratio (%) of Equatorial Guinea in 1974 to that in 2001?
Keep it short and to the point. 0.87. What is the ratio of the Gross enrolment ratio (%) of Libya in 1974 to that in 2001?
Offer a terse response. 1.11. What is the ratio of the Gross enrolment ratio (%) in Lower middle income in 1974 to that in 2002?
Provide a succinct answer. 0.82. What is the ratio of the Gross enrolment ratio (%) of Colombia in 1974 to that in 2002?
Offer a very short reply. 0.95. What is the ratio of the Gross enrolment ratio (%) of Equatorial Guinea in 1974 to that in 2002?
Provide a succinct answer. 0.89. What is the ratio of the Gross enrolment ratio (%) in Libya in 1974 to that in 2002?
Your response must be concise. 1.12. What is the ratio of the Gross enrolment ratio (%) in Lower middle income in 1981 to that in 1983?
Ensure brevity in your answer.  0.96. What is the ratio of the Gross enrolment ratio (%) of Colombia in 1981 to that in 1983?
Provide a succinct answer. 1.08. What is the ratio of the Gross enrolment ratio (%) of Equatorial Guinea in 1981 to that in 1983?
Give a very brief answer. 0.8. What is the ratio of the Gross enrolment ratio (%) in Lower middle income in 1981 to that in 1999?
Ensure brevity in your answer.  0.92. What is the ratio of the Gross enrolment ratio (%) in Colombia in 1981 to that in 1999?
Offer a very short reply. 1.01. What is the ratio of the Gross enrolment ratio (%) of Equatorial Guinea in 1981 to that in 1999?
Your answer should be very brief. 1.21. What is the ratio of the Gross enrolment ratio (%) of Libya in 1981 to that in 1999?
Ensure brevity in your answer.  1.08. What is the ratio of the Gross enrolment ratio (%) in Lower middle income in 1981 to that in 2001?
Your answer should be compact. 0.91. What is the ratio of the Gross enrolment ratio (%) in Colombia in 1981 to that in 2001?
Provide a short and direct response. 1.03. What is the ratio of the Gross enrolment ratio (%) of Equatorial Guinea in 1981 to that in 2001?
Your response must be concise. 1.21. What is the ratio of the Gross enrolment ratio (%) of Libya in 1981 to that in 2001?
Provide a succinct answer. 1.14. What is the ratio of the Gross enrolment ratio (%) in Lower middle income in 1981 to that in 2002?
Offer a terse response. 0.9. What is the ratio of the Gross enrolment ratio (%) of Colombia in 1981 to that in 2002?
Your answer should be very brief. 1.03. What is the ratio of the Gross enrolment ratio (%) of Equatorial Guinea in 1981 to that in 2002?
Give a very brief answer. 1.24. What is the ratio of the Gross enrolment ratio (%) of Libya in 1981 to that in 2002?
Provide a succinct answer. 1.15. What is the ratio of the Gross enrolment ratio (%) in Lower middle income in 1983 to that in 1999?
Keep it short and to the point. 0.96. What is the ratio of the Gross enrolment ratio (%) in Colombia in 1983 to that in 1999?
Keep it short and to the point. 0.93. What is the ratio of the Gross enrolment ratio (%) in Equatorial Guinea in 1983 to that in 1999?
Keep it short and to the point. 1.52. What is the ratio of the Gross enrolment ratio (%) in Libya in 1983 to that in 1999?
Your answer should be compact. 1.09. What is the ratio of the Gross enrolment ratio (%) of Lower middle income in 1983 to that in 2001?
Your answer should be compact. 0.94. What is the ratio of the Gross enrolment ratio (%) in Colombia in 1983 to that in 2001?
Provide a succinct answer. 0.95. What is the ratio of the Gross enrolment ratio (%) in Equatorial Guinea in 1983 to that in 2001?
Your answer should be very brief. 1.52. What is the ratio of the Gross enrolment ratio (%) in Libya in 1983 to that in 2001?
Keep it short and to the point. 1.15. What is the ratio of the Gross enrolment ratio (%) in Lower middle income in 1983 to that in 2002?
Provide a short and direct response. 0.94. What is the ratio of the Gross enrolment ratio (%) of Colombia in 1983 to that in 2002?
Ensure brevity in your answer.  0.95. What is the ratio of the Gross enrolment ratio (%) in Equatorial Guinea in 1983 to that in 2002?
Offer a very short reply. 1.56. What is the ratio of the Gross enrolment ratio (%) in Libya in 1983 to that in 2002?
Offer a terse response. 1.17. What is the ratio of the Gross enrolment ratio (%) in Lower middle income in 1999 to that in 2001?
Keep it short and to the point. 0.98. What is the ratio of the Gross enrolment ratio (%) of Colombia in 1999 to that in 2001?
Offer a terse response. 1.02. What is the ratio of the Gross enrolment ratio (%) in Libya in 1999 to that in 2001?
Keep it short and to the point. 1.06. What is the ratio of the Gross enrolment ratio (%) in Lower middle income in 1999 to that in 2002?
Ensure brevity in your answer.  0.98. What is the ratio of the Gross enrolment ratio (%) of Colombia in 1999 to that in 2002?
Your answer should be very brief. 1.01. What is the ratio of the Gross enrolment ratio (%) of Equatorial Guinea in 1999 to that in 2002?
Keep it short and to the point. 1.03. What is the ratio of the Gross enrolment ratio (%) in Libya in 1999 to that in 2002?
Offer a very short reply. 1.07. What is the ratio of the Gross enrolment ratio (%) in Equatorial Guinea in 2001 to that in 2002?
Your answer should be very brief. 1.02. What is the difference between the highest and the second highest Gross enrolment ratio (%) of Lower middle income?
Your answer should be compact. 0.59. What is the difference between the highest and the second highest Gross enrolment ratio (%) of Colombia?
Offer a terse response. 1.52. What is the difference between the highest and the second highest Gross enrolment ratio (%) of Equatorial Guinea?
Provide a succinct answer. 35.12. What is the difference between the highest and the second highest Gross enrolment ratio (%) of Libya?
Offer a terse response. 1.26. What is the difference between the highest and the lowest Gross enrolment ratio (%) of Lower middle income?
Keep it short and to the point. 20.78. What is the difference between the highest and the lowest Gross enrolment ratio (%) in Colombia?
Provide a succinct answer. 11.29. What is the difference between the highest and the lowest Gross enrolment ratio (%) of Equatorial Guinea?
Offer a terse response. 80.85. What is the difference between the highest and the lowest Gross enrolment ratio (%) of Libya?
Keep it short and to the point. 24.37. 